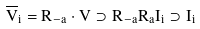<formula> <loc_0><loc_0><loc_500><loc_500>\overline { V } _ { i } = R _ { - a } \cdot V \supset R _ { - a } R _ { a } I _ { i } \supset I _ { i }</formula> 